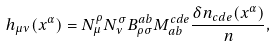Convert formula to latex. <formula><loc_0><loc_0><loc_500><loc_500>h _ { \mu \nu } ( x ^ { \alpha } ) = N ^ { \rho } _ { \mu } N ^ { \sigma } _ { \nu } B ^ { a b } _ { \rho \sigma } M ^ { c d e } _ { a b } \frac { \delta n _ { c d e } ( x ^ { \alpha } ) } { n } ,</formula> 